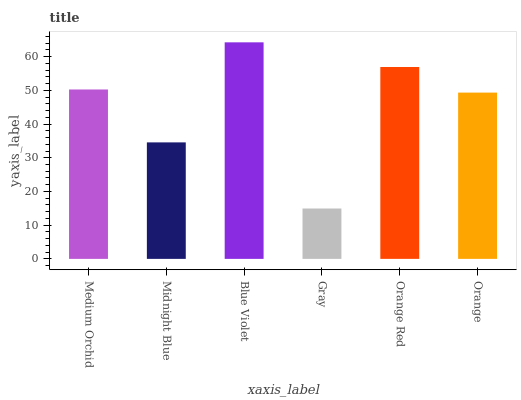Is Gray the minimum?
Answer yes or no. Yes. Is Blue Violet the maximum?
Answer yes or no. Yes. Is Midnight Blue the minimum?
Answer yes or no. No. Is Midnight Blue the maximum?
Answer yes or no. No. Is Medium Orchid greater than Midnight Blue?
Answer yes or no. Yes. Is Midnight Blue less than Medium Orchid?
Answer yes or no. Yes. Is Midnight Blue greater than Medium Orchid?
Answer yes or no. No. Is Medium Orchid less than Midnight Blue?
Answer yes or no. No. Is Medium Orchid the high median?
Answer yes or no. Yes. Is Orange the low median?
Answer yes or no. Yes. Is Midnight Blue the high median?
Answer yes or no. No. Is Midnight Blue the low median?
Answer yes or no. No. 